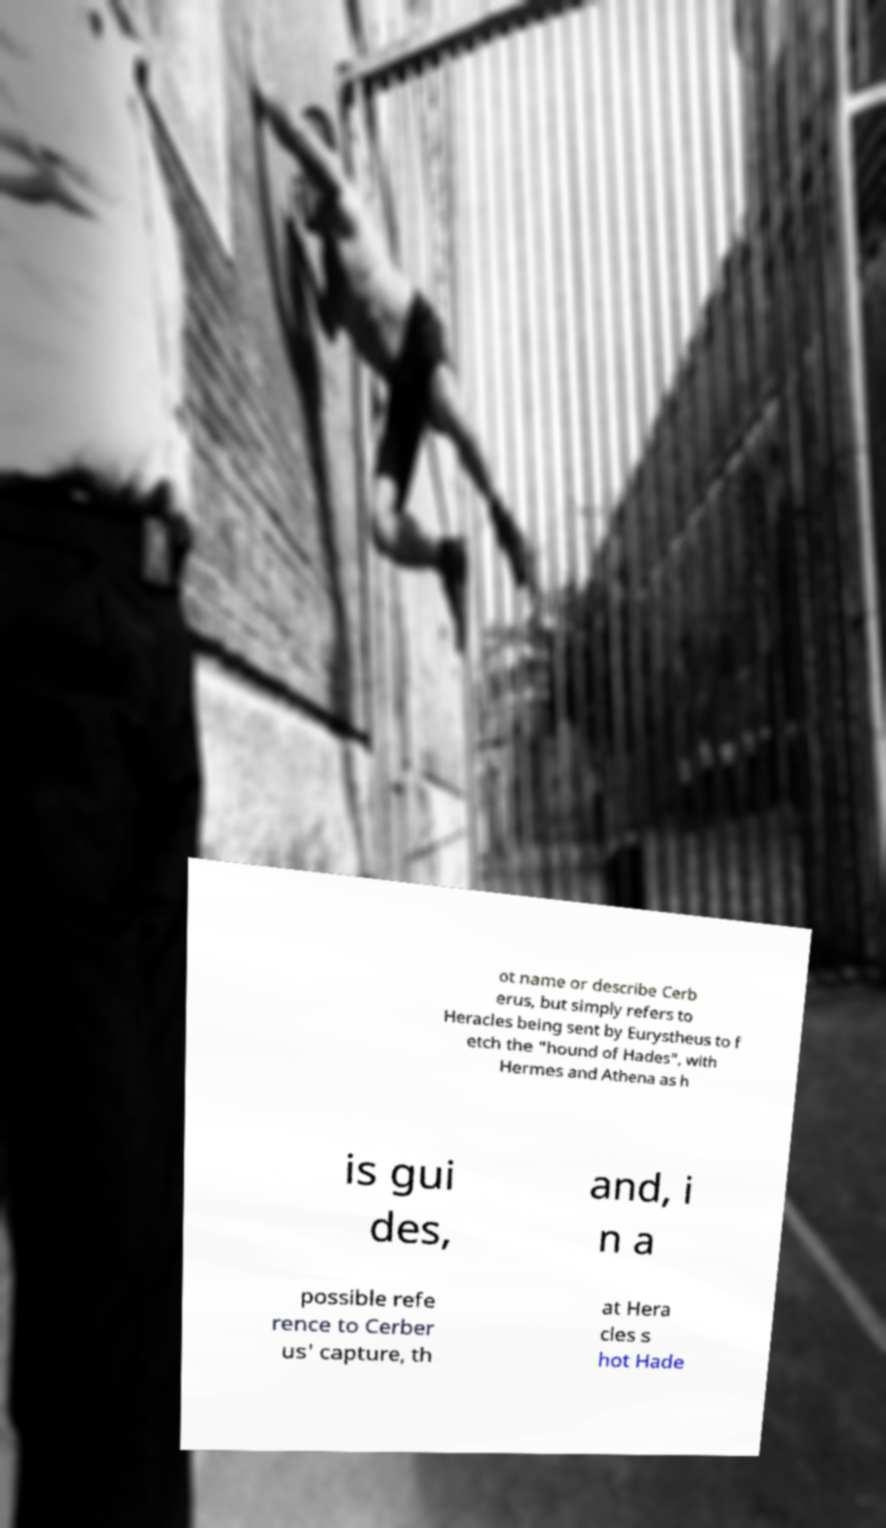There's text embedded in this image that I need extracted. Can you transcribe it verbatim? ot name or describe Cerb erus, but simply refers to Heracles being sent by Eurystheus to f etch the "hound of Hades", with Hermes and Athena as h is gui des, and, i n a possible refe rence to Cerber us' capture, th at Hera cles s hot Hade 